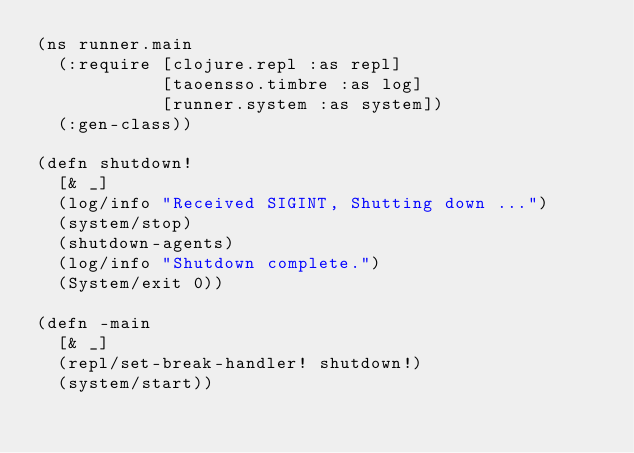<code> <loc_0><loc_0><loc_500><loc_500><_Clojure_>(ns runner.main
  (:require [clojure.repl :as repl]
            [taoensso.timbre :as log]
            [runner.system :as system])
  (:gen-class))

(defn shutdown!
  [& _]
  (log/info "Received SIGINT, Shutting down ...")
  (system/stop)
  (shutdown-agents)
  (log/info "Shutdown complete.")
  (System/exit 0))

(defn -main
  [& _]
  (repl/set-break-handler! shutdown!)
  (system/start))
</code> 